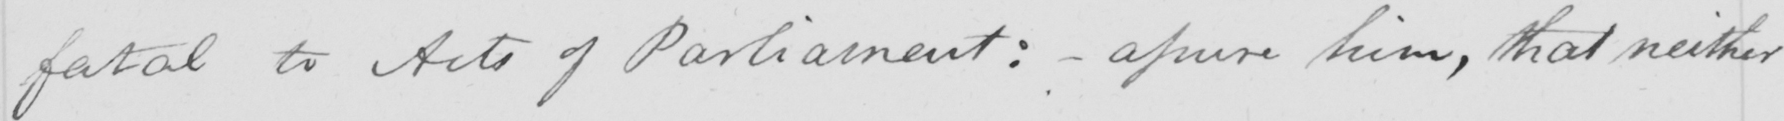What text is written in this handwritten line? fatal to Acts of Parliament: _ assure him, that neither 